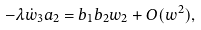Convert formula to latex. <formula><loc_0><loc_0><loc_500><loc_500>- \lambda \dot { w } _ { 3 } a _ { 2 } = b _ { 1 } b _ { 2 } w _ { 2 } + O ( w ^ { 2 } ) ,</formula> 